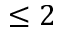Convert formula to latex. <formula><loc_0><loc_0><loc_500><loc_500>\leq 2</formula> 